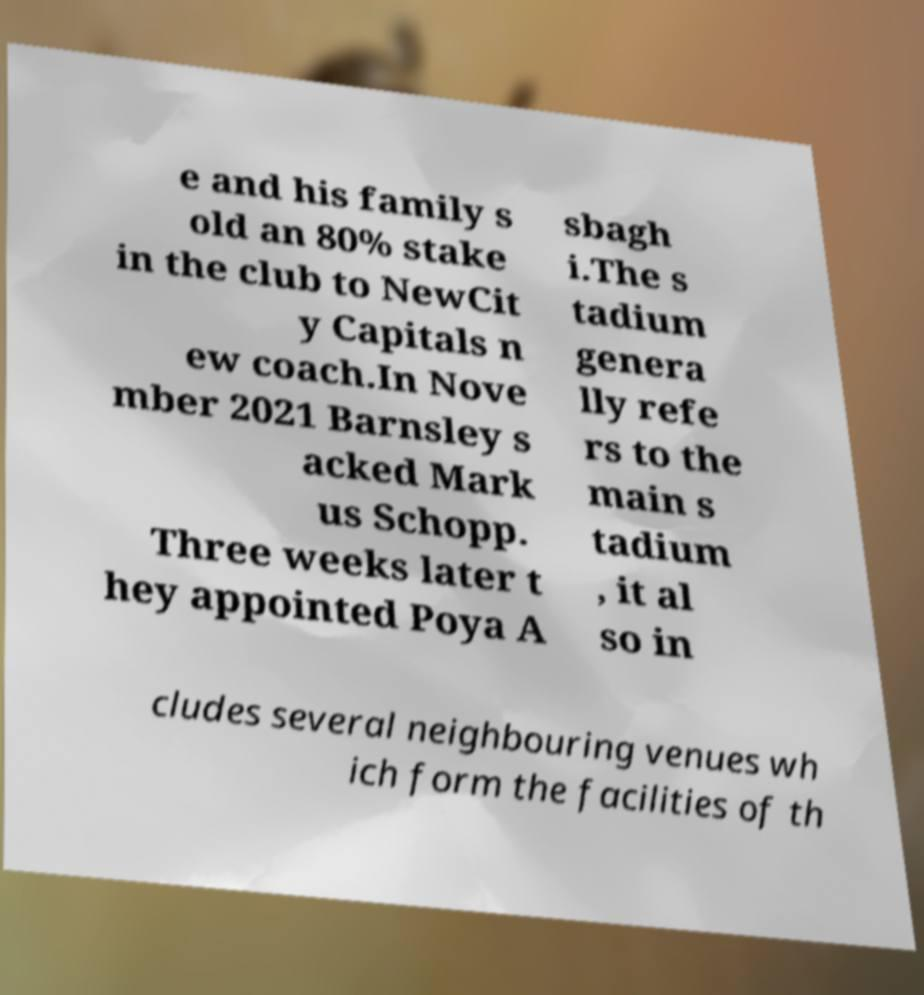For documentation purposes, I need the text within this image transcribed. Could you provide that? e and his family s old an 80% stake in the club to NewCit y Capitals n ew coach.In Nove mber 2021 Barnsley s acked Mark us Schopp. Three weeks later t hey appointed Poya A sbagh i.The s tadium genera lly refe rs to the main s tadium , it al so in cludes several neighbouring venues wh ich form the facilities of th 